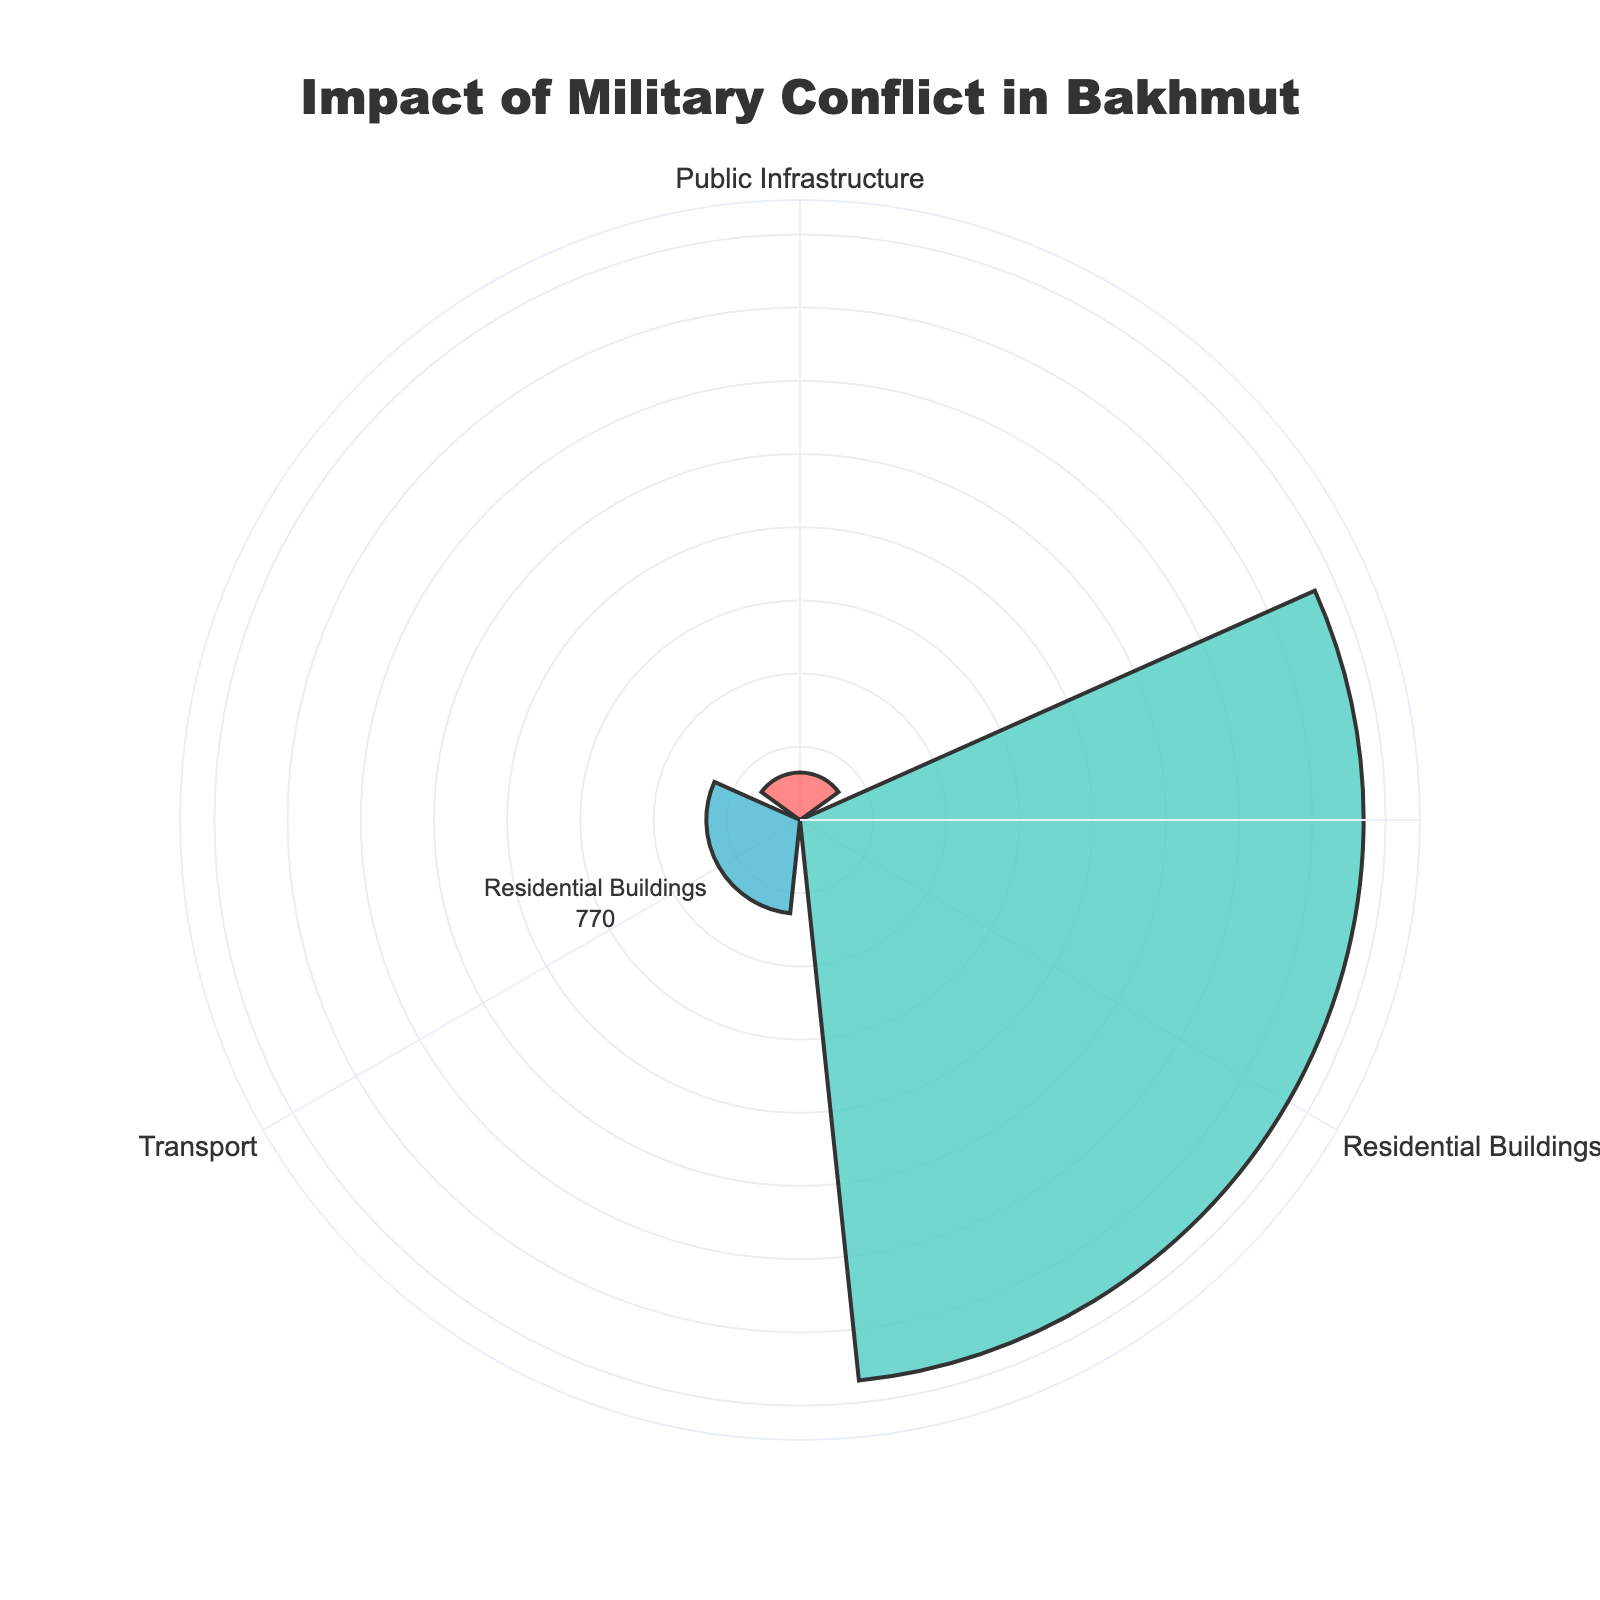what is the title of the figure? The title is prominently displayed at the top of the figure, often in a larger font size and different color.
Answer: Impact of Military Conflict in Bakhmut What category has the highest impact? By examining the radial distances on the rose chart, it's clear that the category with the longest bars has the highest impact.
Answer: Residential Buildings Which category has the lowest impact? The shortest bar in the rose chart represents the category with the lowest impact, readily identifiable by its limited radial extent.
Answer: Public Infrastructure How many units have been damaged in Private Houses? The rose chart includes annotations for specific categories, allowing direct reading of numerical values for each category segment. Locate the value associated with Private Houses.
Answer: 420 What is the combined impact on the Public Infrastructure category? Sum the values associated with all subcategories under 'Public Infrastructure.' This includes Schools and Hospitals.
Answer: 65 Compare the impact between Residential Buildings and Transport. Which is greater and by how much? Add the impacts of subcategories within 'Residential Buildings' and 'Transport.' Subtract the total impact of Transport from that of Residential Buildings to find the difference.
Answer: Residential Buildings; 642 What is the average impact across all the categories? Sum the impacts of all categories (Residential Buildings, Public Infrastructure, and Transport) and divide by the number of categories.
Answer: 204.33 Which subcategory within Residential Buildings has the highest impact? Compare the respective impacts within Residential Buildings by directly observing the annotated values in the figure.
Answer: Private Houses What percentage of the total impact does the Roads (km) category represent? Divide the impact of Roads (km) by the combined impact of all categories, then multiply by 100 to convert it to a percentage.
Answer: 12.99% What is the cumulative impact of all types of infrastructures and transport? Add the numerical impacts of all transport and public infrastructure-related categories, including Roads (km), Bridges, Schools, and Hospitals.
Answer: 193 